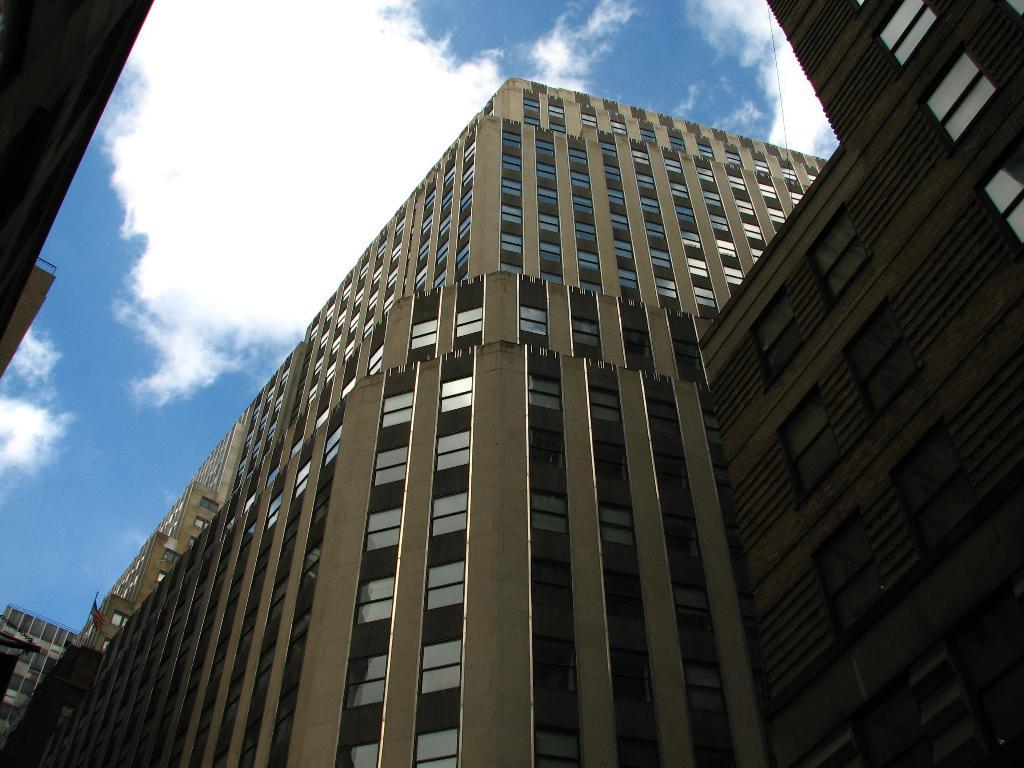What type of structures can be seen in the image? There are buildings in the image. What is visible at the top of the image? The sky is visible at the top of the image. What can be observed in the sky? Clouds are present in the sky. What type of twig can be seen floating in the soup in the image? There is no soup or twig present in the image. 